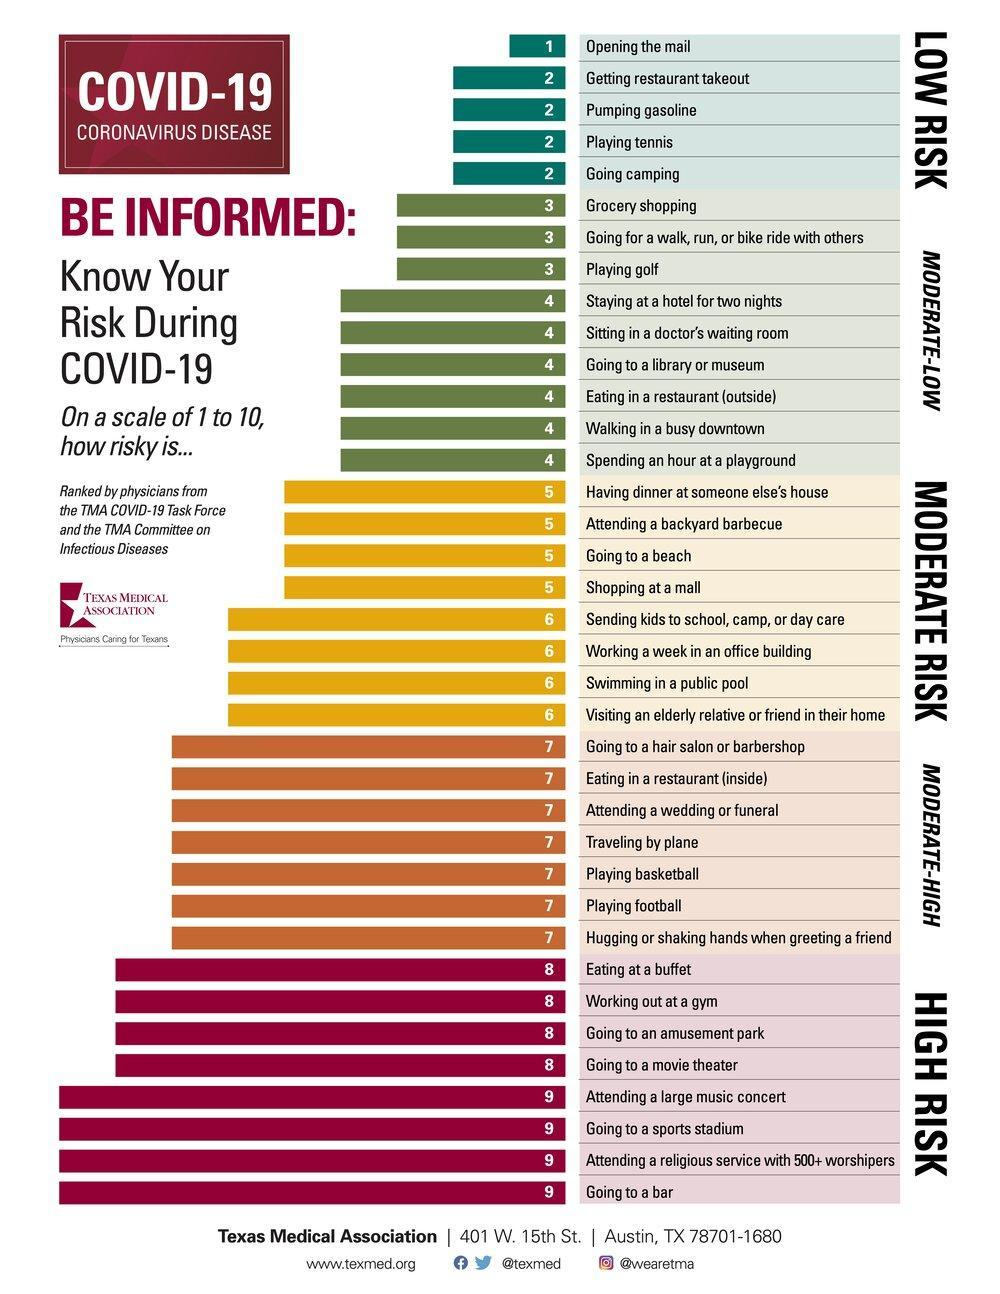Which of these is of lowest COVID-19 risk - playing golf, playing basketball or playing tennis?
Answer the question with a short phrase. playing tennis What is listed third in the moderate risk category? Going to a beach What is the risk category associated with attending a religious service with above 500 worshippers? High risk Grocery shopping is listed in which risk category? Moderate-low Which is of higher risk - getting restaurant takeout or eating in a restaurant (inside)? Eating in a restaurant (inside) Playing football is listed in which risk category? Moderate-high What is listed third from the last in the high risk category? Going to a sports stadium How many items are listed in risk level 2? 4 How many items are listed in risk level 7? 7 Which is of higher COVID-19 risk - travelling by plane or going camping? travelling by plane 